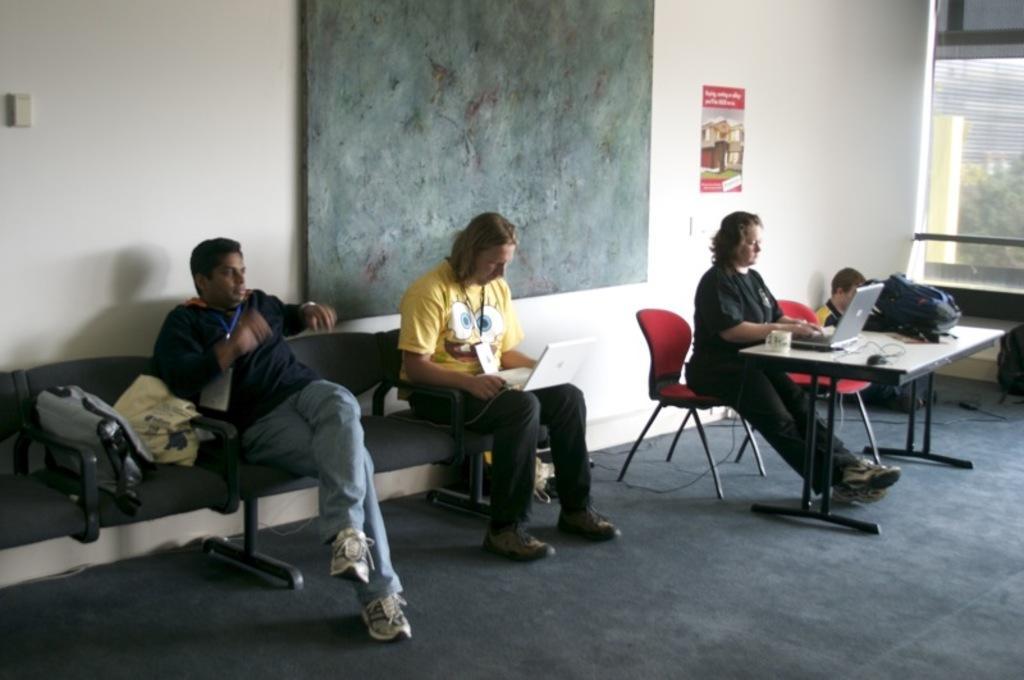Please provide a concise description of this image. In this picture there are three people sitting on the chair. There is a laptop, cup, bag on the table. There is a man sitting on the ground. There is carpet and poster on the wall. 